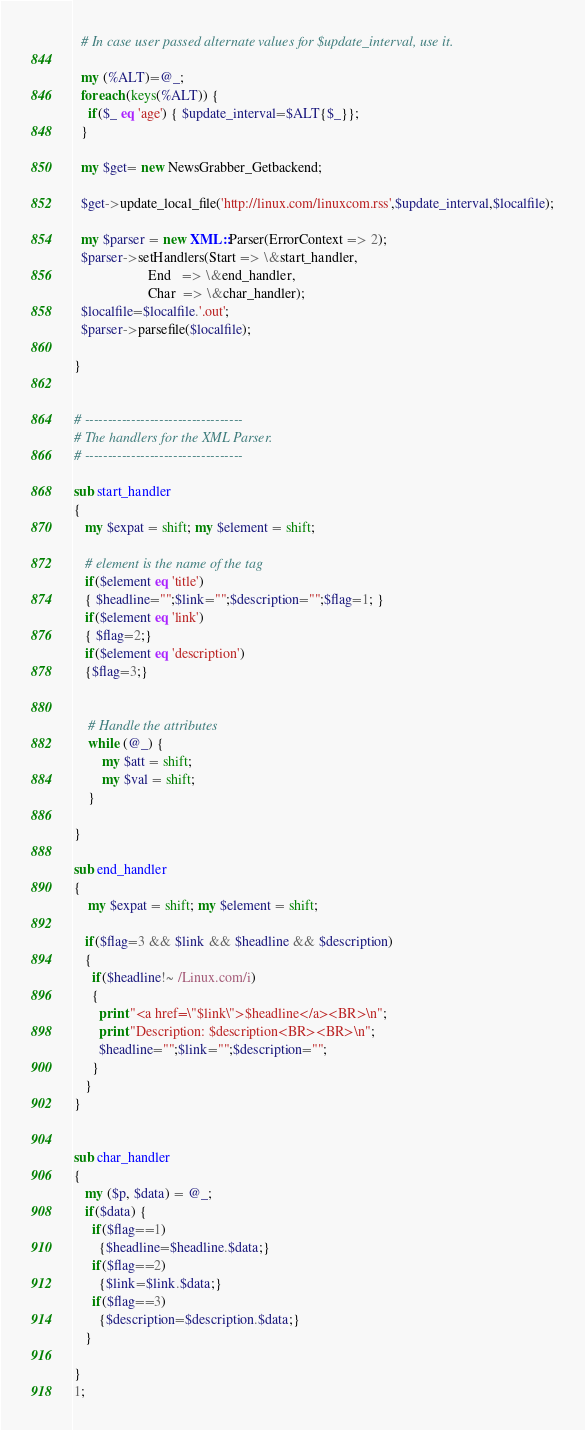<code> <loc_0><loc_0><loc_500><loc_500><_Perl_>  # In case user passed alternate values for $update_interval, use it.
  
  my (%ALT)=@_;
  foreach (keys(%ALT)) {
    if($_ eq 'age') { $update_interval=$ALT{$_}};
  }

  my $get= new NewsGrabber_Getbackend;

  $get->update_local_file('http://linux.com/linuxcom.rss',$update_interval,$localfile);

  my $parser = new XML::Parser(ErrorContext => 2);
  $parser->setHandlers(Start => \&start_handler,
                     End   => \&end_handler,
                     Char  => \&char_handler);
  $localfile=$localfile.'.out';
  $parser->parsefile($localfile);

}


# ----------------------------------
# The handlers for the XML Parser.
# ----------------------------------

sub start_handler
{
   my $expat = shift; my $element = shift;

   # element is the name of the tag
   if($element eq 'title')
   { $headline="";$link="";$description="";$flag=1; } 
   if($element eq 'link')
   { $flag=2;}
   if($element eq 'description')
   {$flag=3;}

	
    # Handle the attributes
    while (@_) {
        my $att = shift;
        my $val = shift;
    }

}

sub end_handler
{
    my $expat = shift; my $element = shift;
   
   if($flag=3 && $link && $headline && $description) 
   {
     if($headline!~ /Linux.com/i)
     {
       print "<a href=\"$link\">$headline</a><BR>\n";
       print "Description: $description<BR><BR>\n";
       $headline="";$link="";$description="";
     }
   }
}


sub char_handler
{
   my ($p, $data) = @_;
   if($data) {
     if($flag==1)
       {$headline=$headline.$data;}
     if($flag==2)
       {$link=$link.$data;}
     if($flag==3)
       {$description=$description.$data;}
   }

}
1;
</code> 